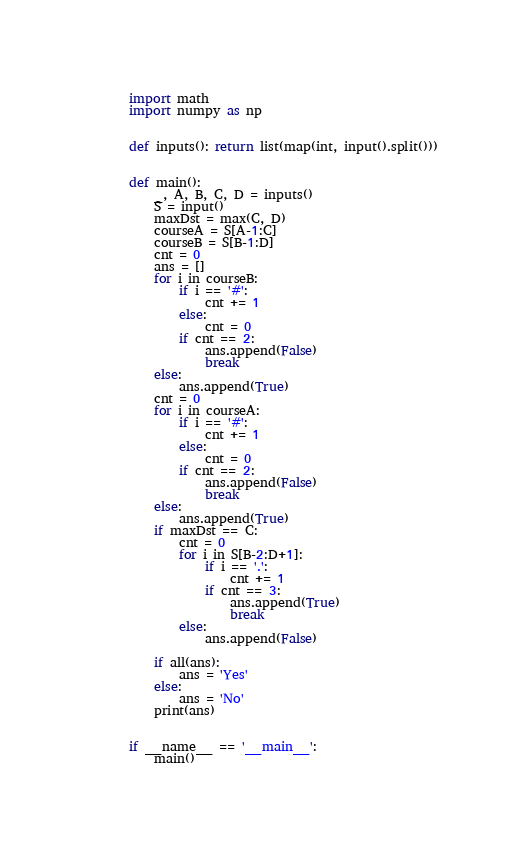<code> <loc_0><loc_0><loc_500><loc_500><_Python_>import math
import numpy as np


def inputs(): return list(map(int, input().split()))


def main():
    _, A, B, C, D = inputs()
    S = input()
    maxDst = max(C, D)
    courseA = S[A-1:C]
    courseB = S[B-1:D]
    cnt = 0
    ans = []
    for i in courseB:
        if i == '#':
            cnt += 1
        else:
            cnt = 0
        if cnt == 2:
            ans.append(False)
            break
    else:
        ans.append(True)
    cnt = 0
    for i in courseA:
        if i == '#':
            cnt += 1
        else:
            cnt = 0
        if cnt == 2:
            ans.append(False)
            break
    else:
        ans.append(True)
    if maxDst == C:
        cnt = 0
        for i in S[B-2:D+1]:
            if i == '.':
                cnt += 1
            if cnt == 3:
                ans.append(True)
                break
        else:
            ans.append(False)

    if all(ans):
        ans = 'Yes'
    else:
        ans = 'No'
    print(ans)


if __name__ == '__main__':
    main()
</code> 